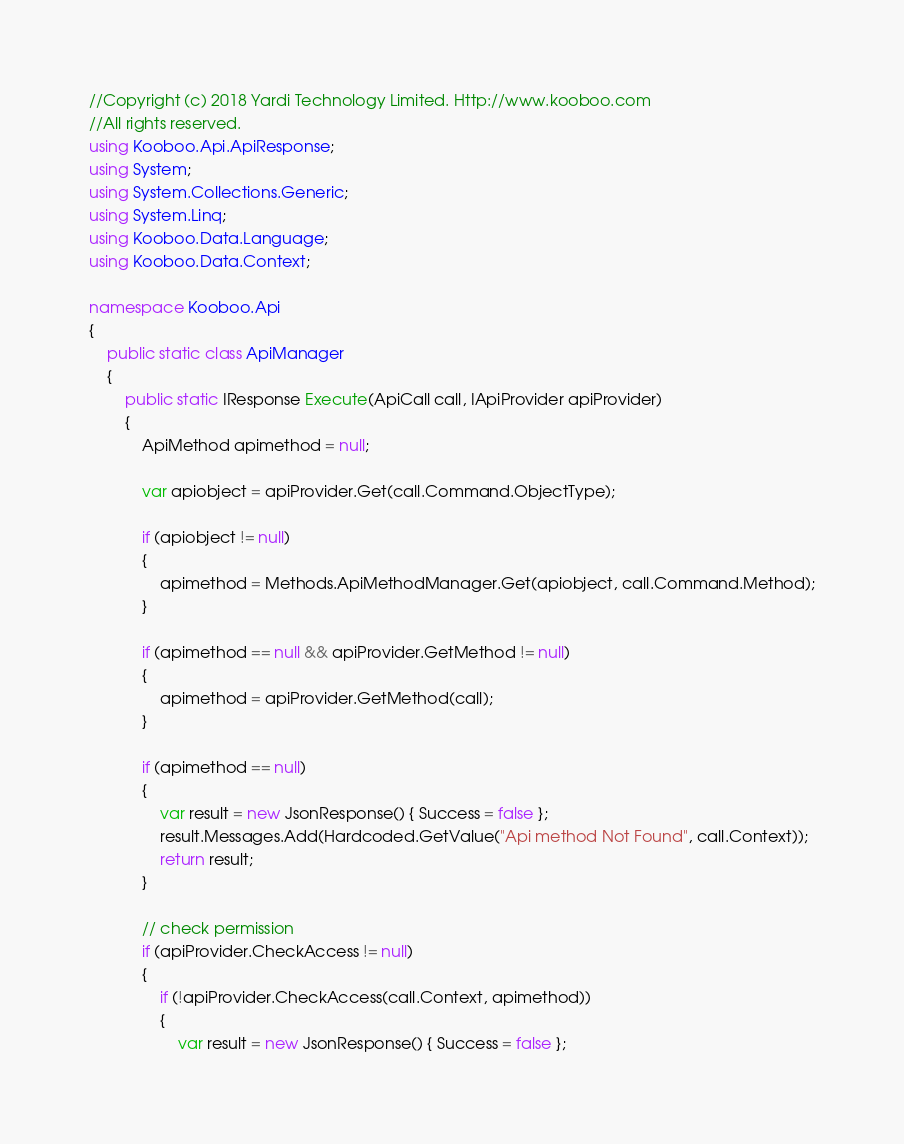<code> <loc_0><loc_0><loc_500><loc_500><_C#_>//Copyright (c) 2018 Yardi Technology Limited. Http://www.kooboo.com 
//All rights reserved.
using Kooboo.Api.ApiResponse;
using System;
using System.Collections.Generic;
using System.Linq;
using Kooboo.Data.Language;
using Kooboo.Data.Context;

namespace Kooboo.Api
{
    public static class ApiManager
    {
        public static IResponse Execute(ApiCall call, IApiProvider apiProvider)
        {
            ApiMethod apimethod = null;

            var apiobject = apiProvider.Get(call.Command.ObjectType);

            if (apiobject != null)
            {
                apimethod = Methods.ApiMethodManager.Get(apiobject, call.Command.Method);
            }

            if (apimethod == null && apiProvider.GetMethod != null)
            {
                apimethod = apiProvider.GetMethod(call);
            }

            if (apimethod == null)
            {
                var result = new JsonResponse() { Success = false };
                result.Messages.Add(Hardcoded.GetValue("Api method Not Found", call.Context));
                return result;
            }

            // check permission
            if (apiProvider.CheckAccess != null)
            {
                if (!apiProvider.CheckAccess(call.Context, apimethod))
                {
                    var result = new JsonResponse() { Success = false };</code> 